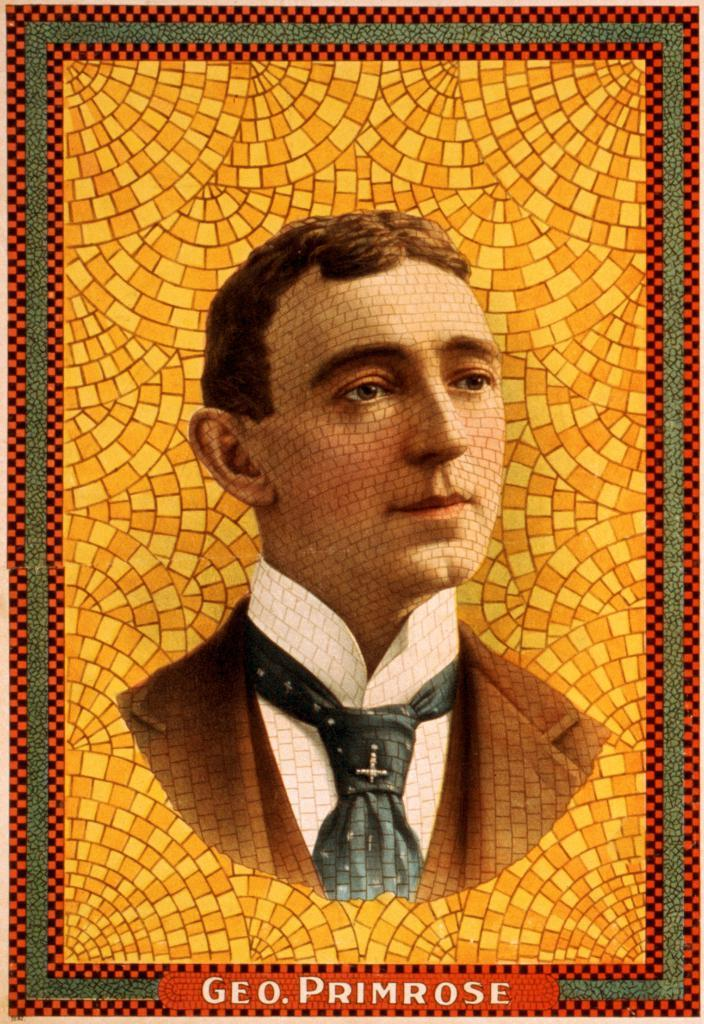What is the main subject of the image? The main subject of the image is a person's picture in a photo frame. What type of crops can be seen growing in the field behind the person's picture in the image? There is no field or crops visible in the image; it only features a person's picture in a photo frame. 